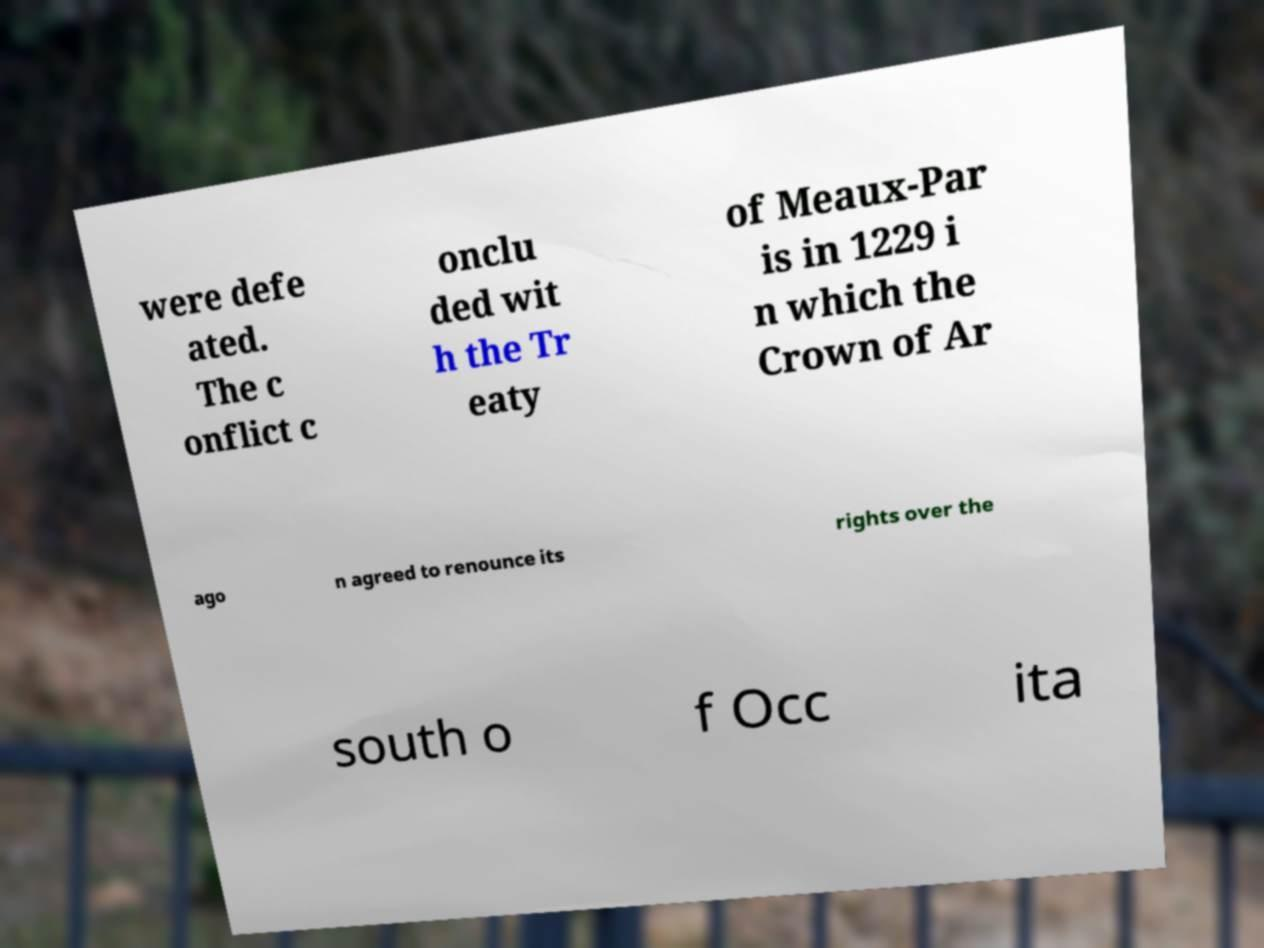Could you assist in decoding the text presented in this image and type it out clearly? were defe ated. The c onflict c onclu ded wit h the Tr eaty of Meaux-Par is in 1229 i n which the Crown of Ar ago n agreed to renounce its rights over the south o f Occ ita 